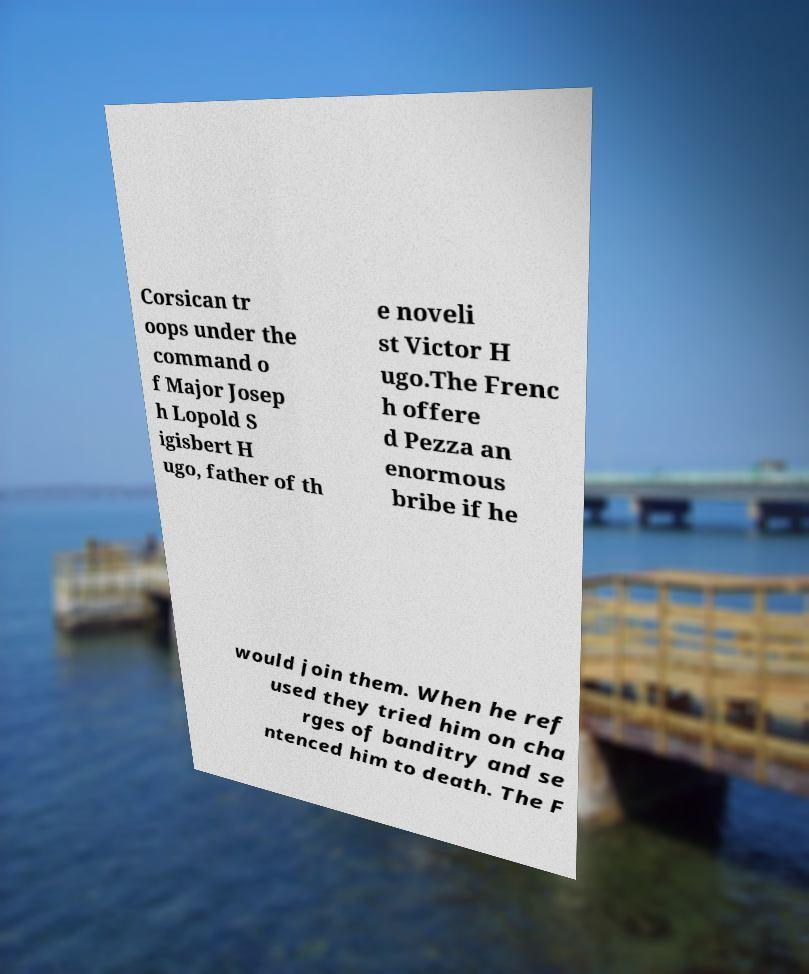Please read and relay the text visible in this image. What does it say? Corsican tr oops under the command o f Major Josep h Lopold S igisbert H ugo, father of th e noveli st Victor H ugo.The Frenc h offere d Pezza an enormous bribe if he would join them. When he ref used they tried him on cha rges of banditry and se ntenced him to death. The F 